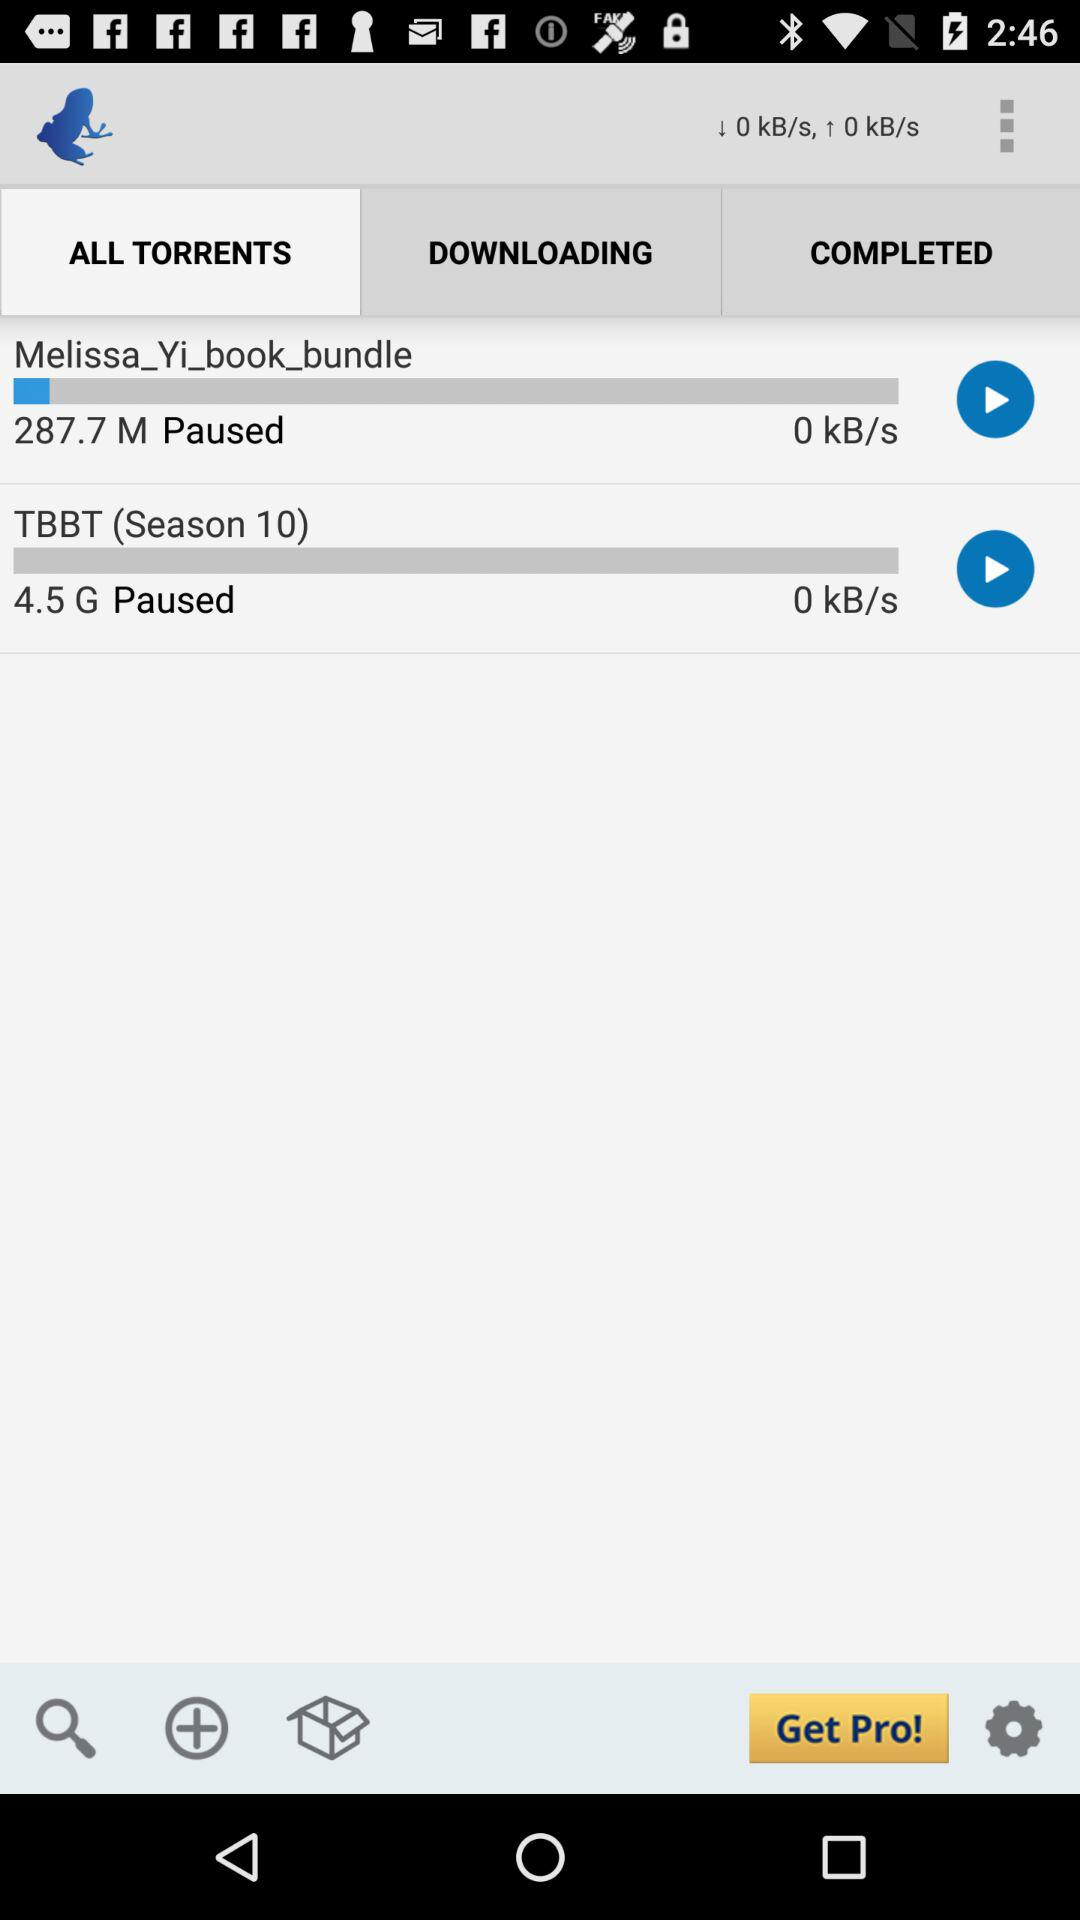What speed is showing? The speed is showing 0 kB/s. 